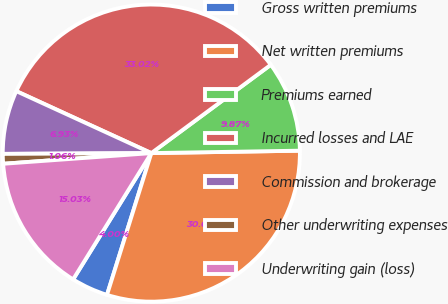Convert chart to OTSL. <chart><loc_0><loc_0><loc_500><loc_500><pie_chart><fcel>Gross written premiums<fcel>Net written premiums<fcel>Premiums earned<fcel>Incurred losses and LAE<fcel>Commission and brokerage<fcel>Other underwriting expenses<fcel>Underwriting gain (loss)<nl><fcel>4.0%<fcel>30.08%<fcel>9.87%<fcel>33.02%<fcel>6.93%<fcel>1.06%<fcel>15.03%<nl></chart> 